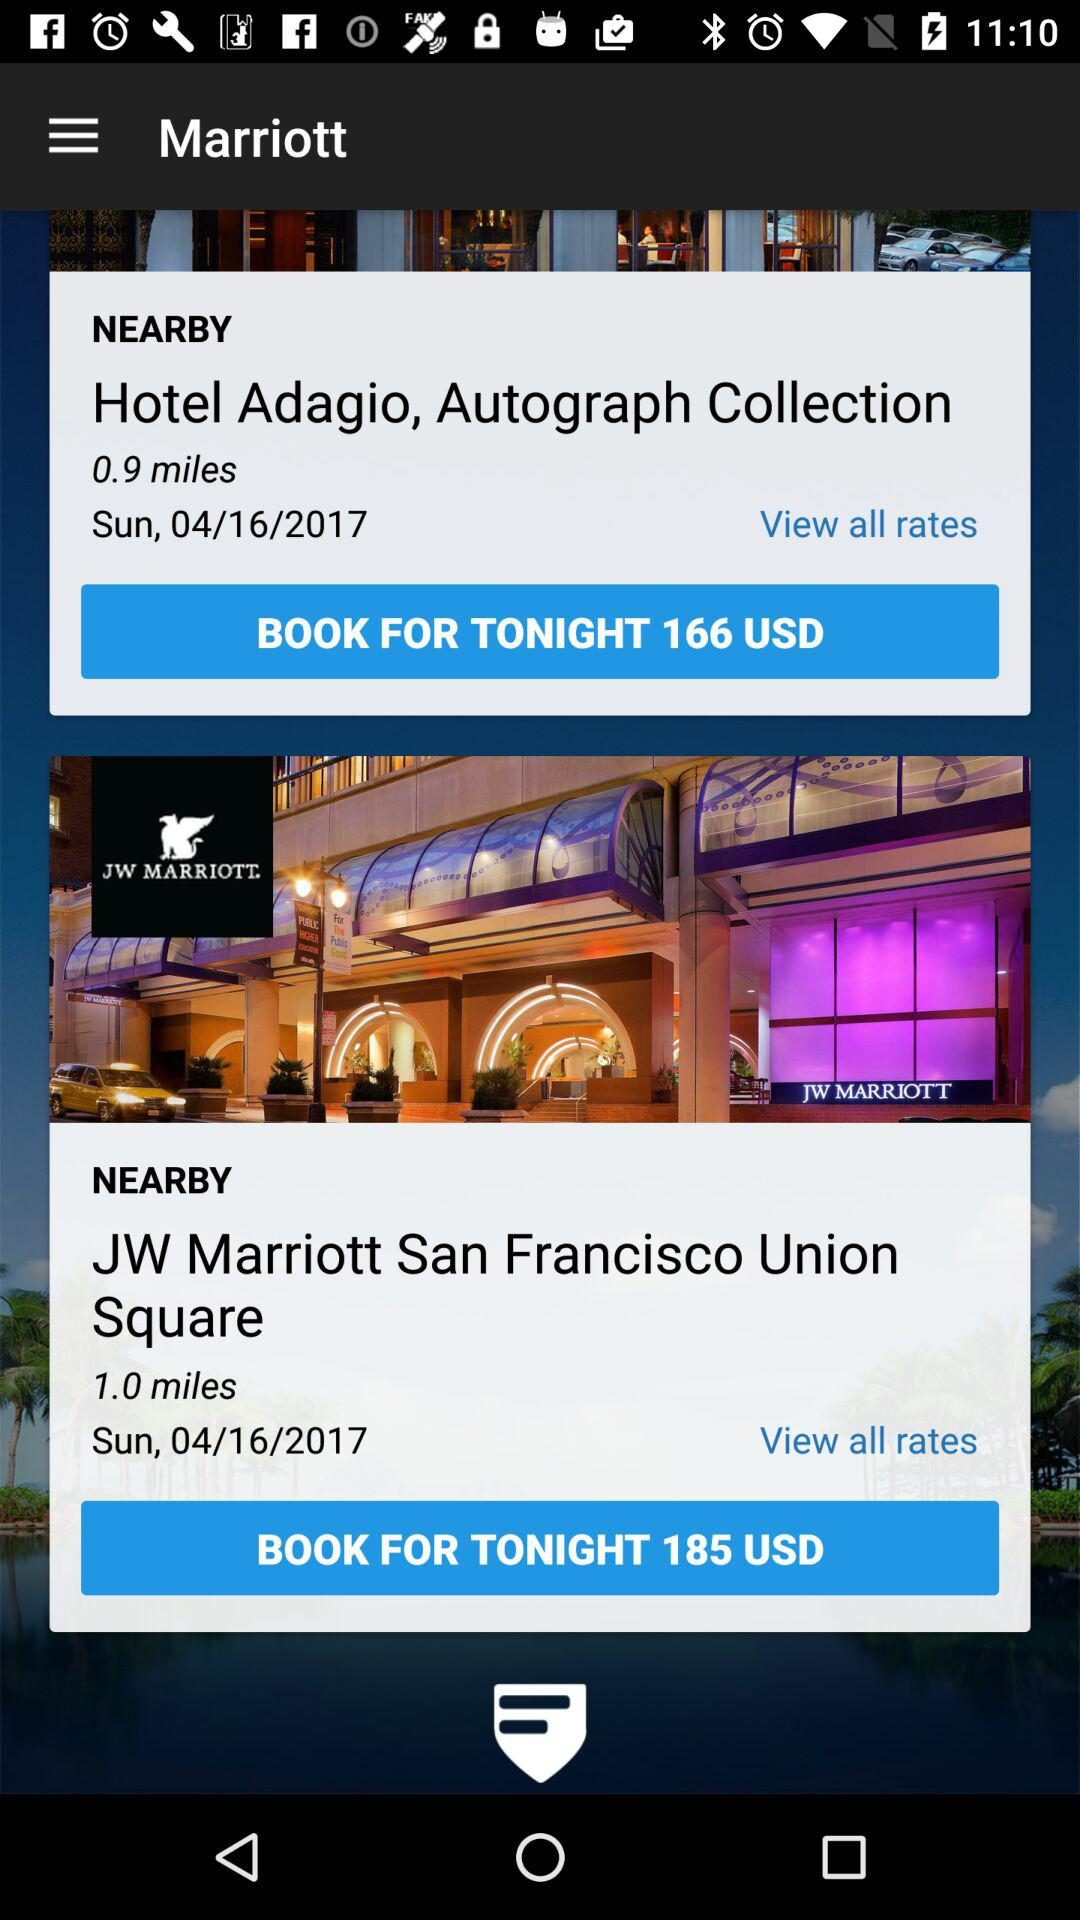What is the day on April 16? The day is Sunday. 